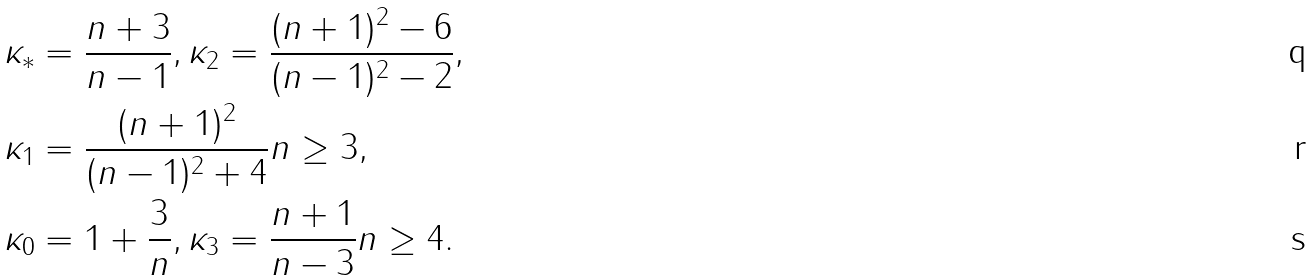Convert formula to latex. <formula><loc_0><loc_0><loc_500><loc_500>\kappa _ { \ast } & = \frac { n + 3 } { n - 1 } , \kappa _ { 2 } = \frac { ( n + 1 ) ^ { 2 } - 6 } { ( n - 1 ) ^ { 2 } - 2 } , \\ \kappa _ { 1 } & = \frac { ( n + 1 ) ^ { 2 } } { ( n - 1 ) ^ { 2 } + 4 } n \geq 3 , \\ \kappa _ { 0 } & = 1 + \frac { 3 } { n } , \kappa _ { 3 } = \frac { n + 1 } { n - 3 } n \geq 4 .</formula> 